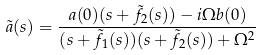Convert formula to latex. <formula><loc_0><loc_0><loc_500><loc_500>\tilde { a } ( s ) = \frac { a ( 0 ) ( s + \tilde { f } _ { 2 } ( s ) ) - i \Omega b ( 0 ) } { ( s + \tilde { f } _ { 1 } ( s ) ) ( s + \tilde { f } _ { 2 } ( s ) ) + \Omega ^ { 2 } }</formula> 